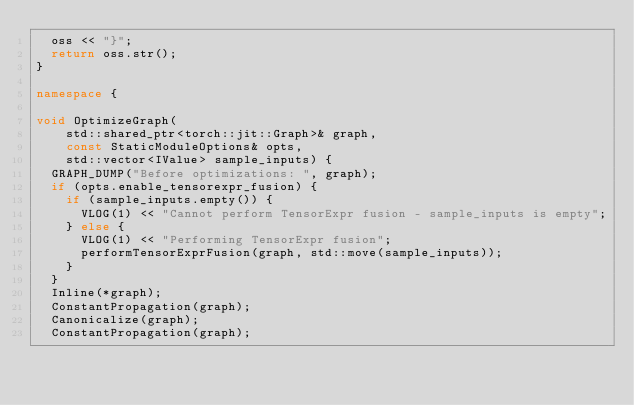Convert code to text. <code><loc_0><loc_0><loc_500><loc_500><_C++_>  oss << "}";
  return oss.str();
}

namespace {

void OptimizeGraph(
    std::shared_ptr<torch::jit::Graph>& graph,
    const StaticModuleOptions& opts,
    std::vector<IValue> sample_inputs) {
  GRAPH_DUMP("Before optimizations: ", graph);
  if (opts.enable_tensorexpr_fusion) {
    if (sample_inputs.empty()) {
      VLOG(1) << "Cannot perform TensorExpr fusion - sample_inputs is empty";
    } else {
      VLOG(1) << "Performing TensorExpr fusion";
      performTensorExprFusion(graph, std::move(sample_inputs));
    }
  }
  Inline(*graph);
  ConstantPropagation(graph);
  Canonicalize(graph);
  ConstantPropagation(graph);</code> 